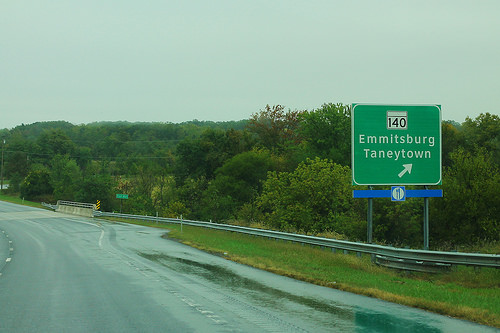<image>
Is the sign behind the tree? No. The sign is not behind the tree. From this viewpoint, the sign appears to be positioned elsewhere in the scene. 